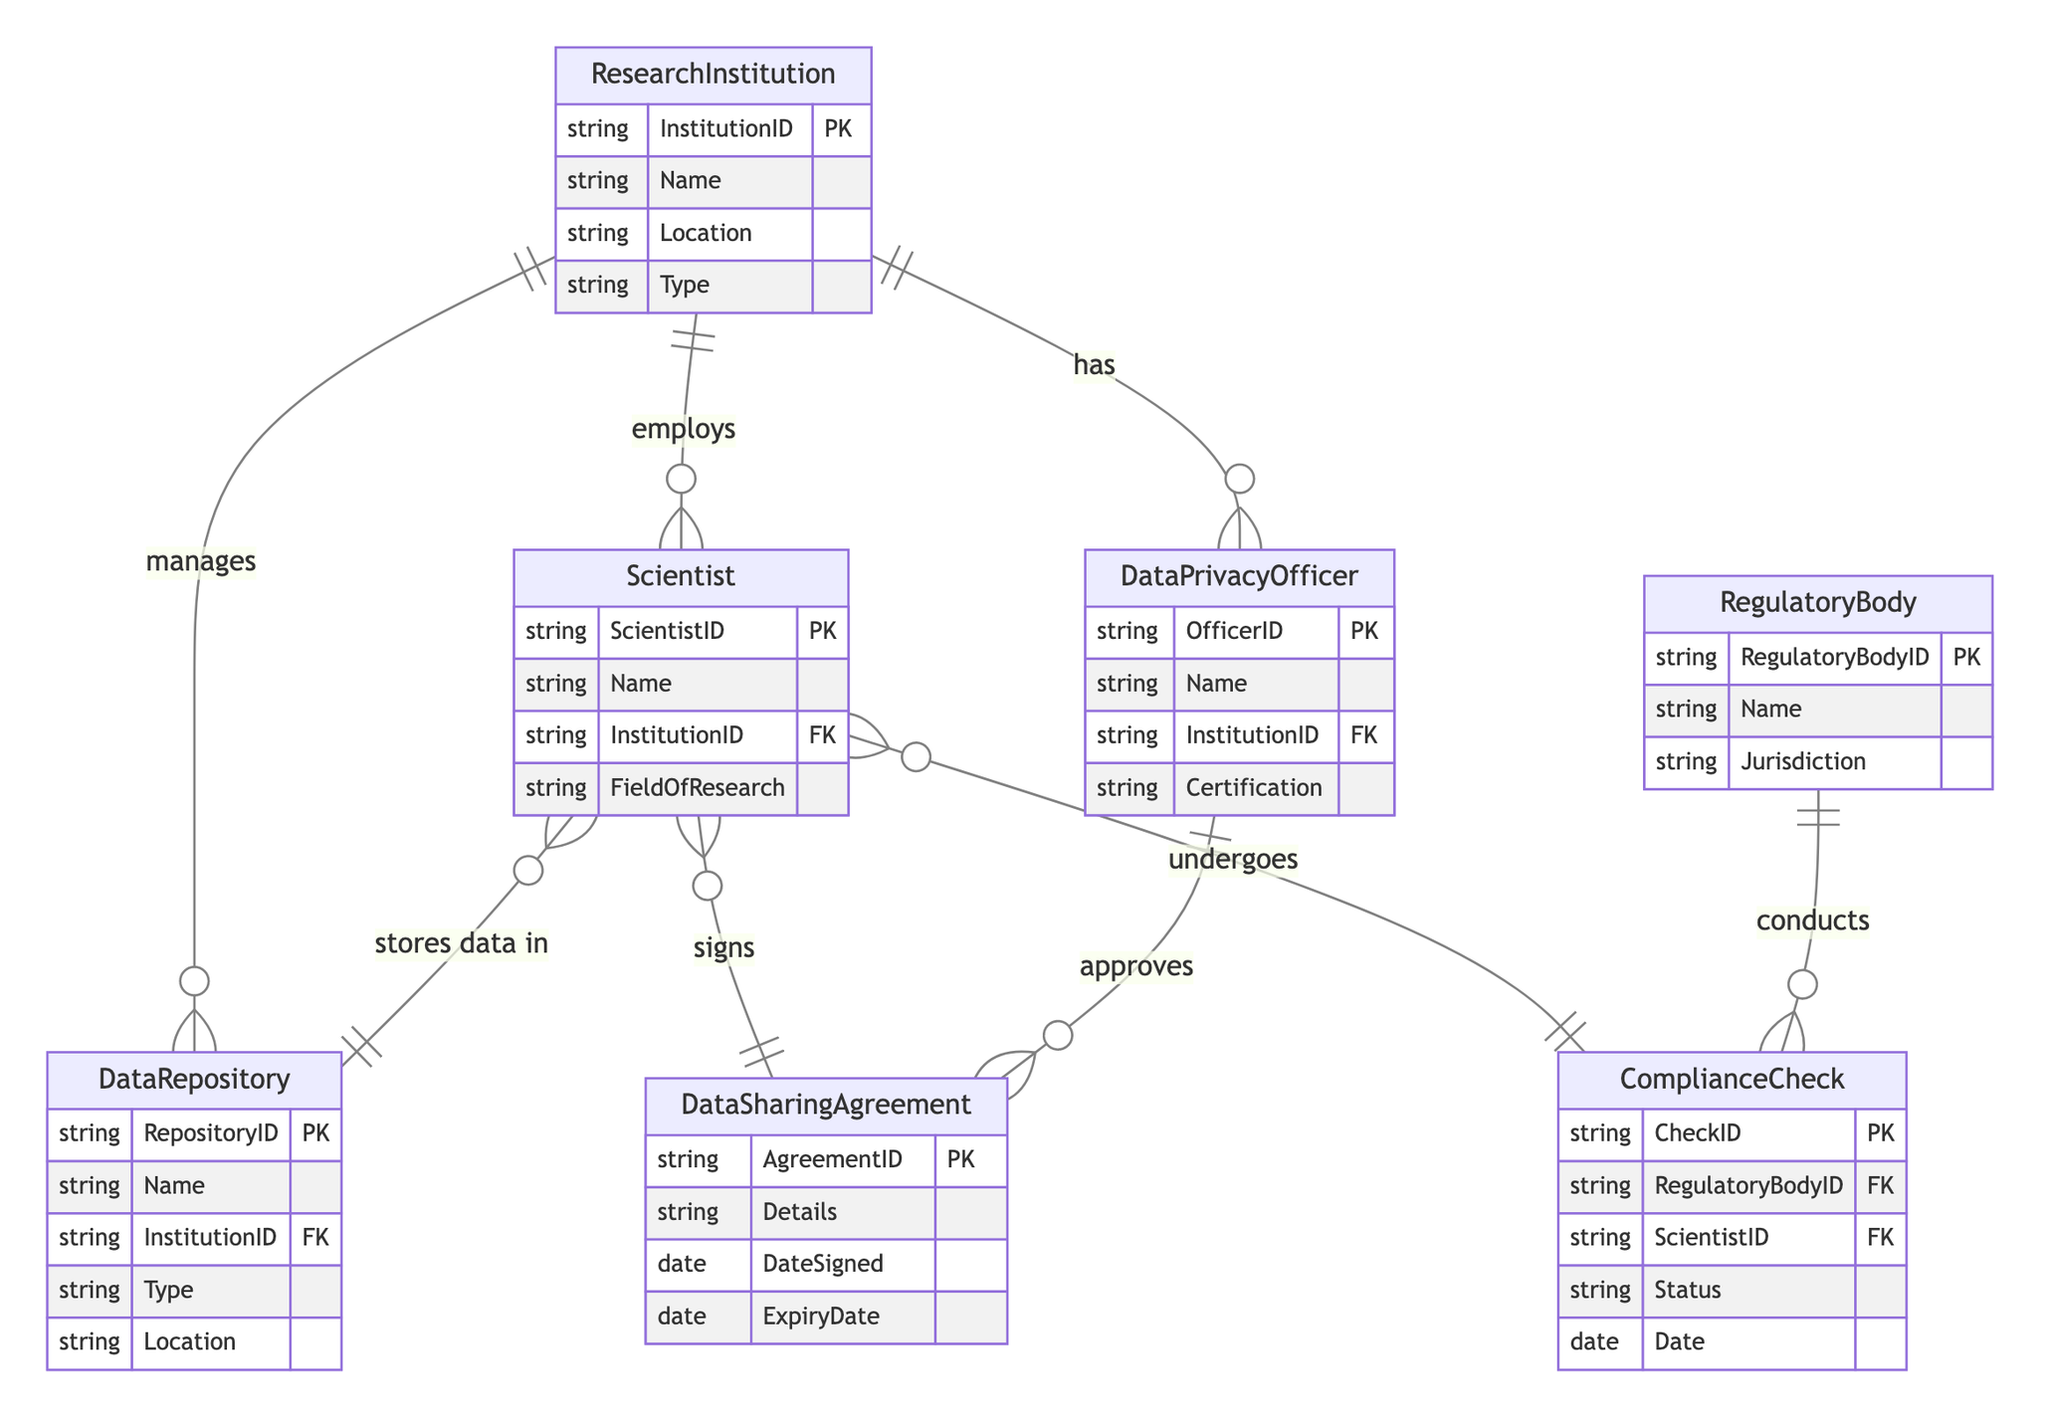What is the primary relationship between Research Institution and Scientist? The diagram shows that Research Institutions employ Scientists, indicated by the relationship line labeled "employs" between the two entities.
Answer: employs How many entities are there in total? By counting the different entities listed in the diagram, there are seven entities: Research Institution, Scientist, Regulatory Body, Data Privacy Officer, Data Repository, Data Sharing Agreement, and Compliance Check.
Answer: seven Who approves the Data Sharing Agreement? The diagram indicates that Data Privacy Officers approve Data Sharing Agreements, connected by the relationship labeled "approves."
Answer: Data Privacy Officer What is the role of the Regulatory Body in the Compliance Check? The diagram illustrates that Regulatory Bodies conduct Compliance Checks, as indicated by the relationship "conducts" linking these two entities.
Answer: conducts Which entity is responsible for managing Data Repositories? According to the diagram, Research Institutions manage Data Repositories, represented by the relationship "manages" that connects these entities.
Answer: Research Institution What is the outcome of a Compliance Check performed on a Scientist? The Compliance Check has a status that indicates the outcome concerning the Scientist checked, shown in the "Status" attribute of the Compliance Check entity.
Answer: Status What relationship exists between Scientist and Data Repository? The diagram shows that Scientists store data in Data Repositories, represented by the relationship "stores data in" connecting these entities.
Answer: stores data in How many attributes are associated with the Data Privacy Officer entity? By looking at the Data Privacy Officer entity in the diagram, it can be noted that it has four attributes: OfficerID, Name, InstitutionID, and Certification.
Answer: four What type of agreements do Scientists sign? The diagram indicates that Scientists sign Data Sharing Agreements, referenced by the relationship labeled "signs" between Scientists and Data Sharing Agreements.
Answer: Data Sharing Agreement 